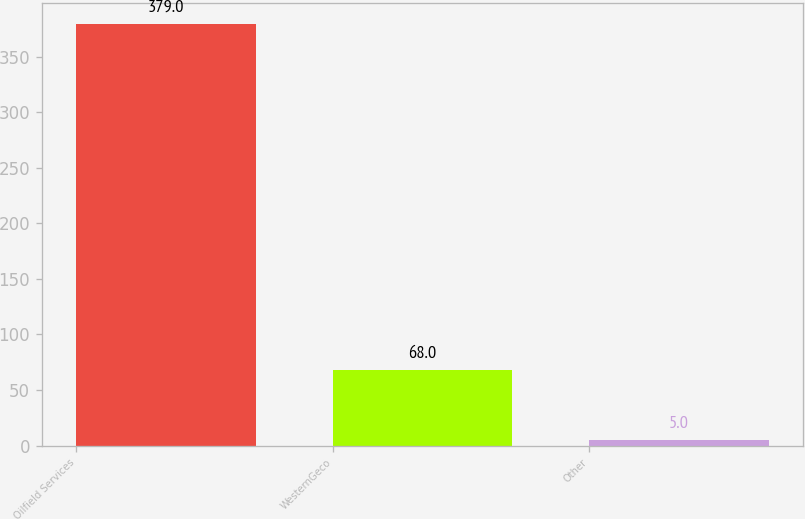<chart> <loc_0><loc_0><loc_500><loc_500><bar_chart><fcel>Oilfield Services<fcel>WesternGeco<fcel>Other<nl><fcel>379<fcel>68<fcel>5<nl></chart> 